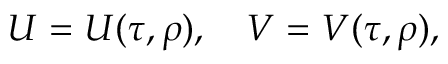<formula> <loc_0><loc_0><loc_500><loc_500>U = U ( \tau , \rho ) , \quad V = V ( \tau , \rho ) ,</formula> 